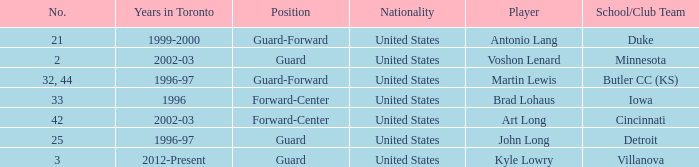How many schools did player number 3 play at? 1.0. 